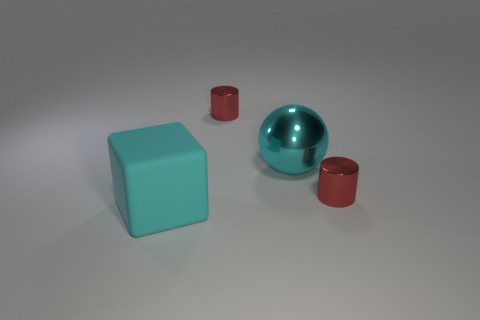Add 3 matte objects. How many objects exist? 7 Subtract all blocks. How many objects are left? 3 Subtract 1 blocks. How many blocks are left? 0 Subtract all brown spheres. Subtract all cyan cylinders. How many spheres are left? 1 Subtract all cyan cylinders. How many purple blocks are left? 0 Subtract all tiny red metal cylinders. Subtract all small cylinders. How many objects are left? 0 Add 2 tiny objects. How many tiny objects are left? 4 Add 4 rubber objects. How many rubber objects exist? 5 Subtract 0 purple balls. How many objects are left? 4 